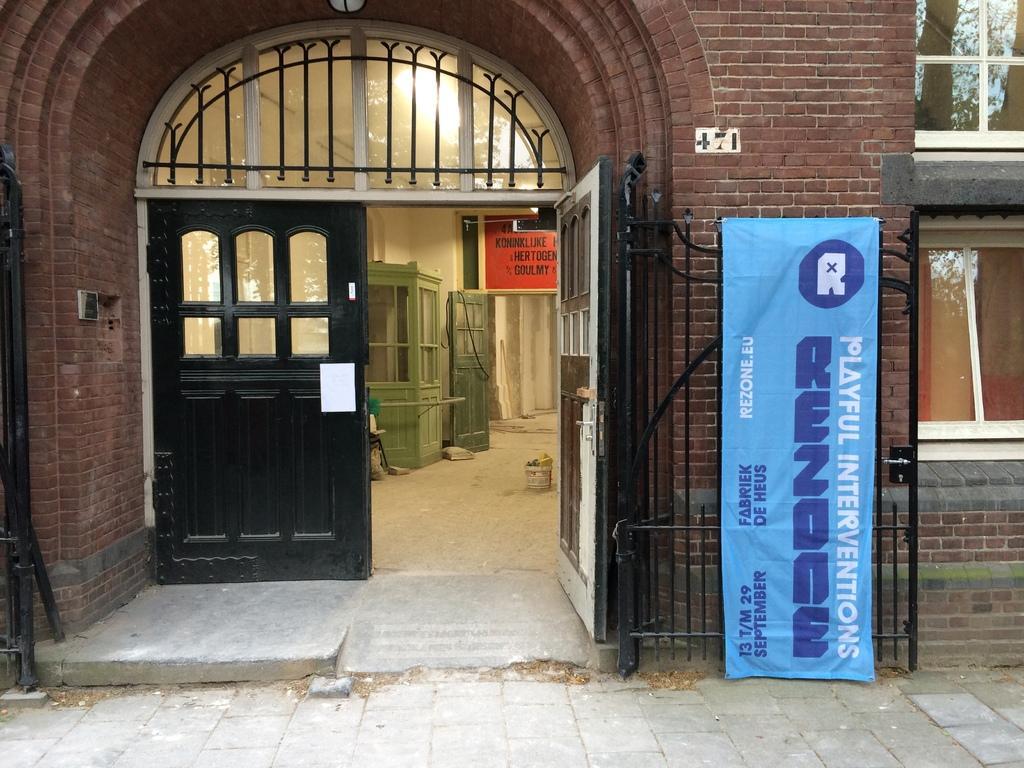Describe this image in one or two sentences. We can see banner on a gate, doors, building and windows, inside the building we can see wall, door, board, objects on the floor and booth. 